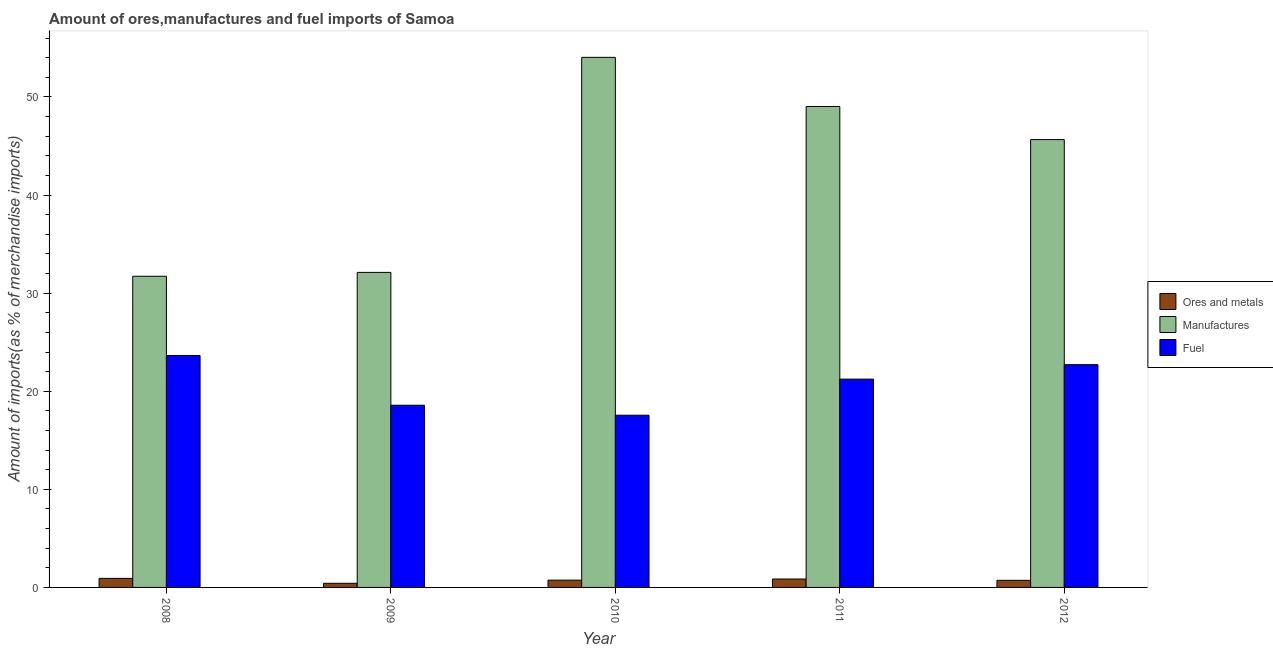How many groups of bars are there?
Your response must be concise. 5. Are the number of bars on each tick of the X-axis equal?
Your answer should be compact. Yes. How many bars are there on the 2nd tick from the left?
Provide a short and direct response. 3. How many bars are there on the 2nd tick from the right?
Offer a very short reply. 3. What is the percentage of fuel imports in 2009?
Keep it short and to the point. 18.58. Across all years, what is the maximum percentage of fuel imports?
Provide a short and direct response. 23.65. Across all years, what is the minimum percentage of manufactures imports?
Ensure brevity in your answer.  31.72. What is the total percentage of ores and metals imports in the graph?
Keep it short and to the point. 3.67. What is the difference between the percentage of manufactures imports in 2009 and that in 2011?
Ensure brevity in your answer.  -16.92. What is the difference between the percentage of ores and metals imports in 2011 and the percentage of manufactures imports in 2008?
Ensure brevity in your answer.  -0.06. What is the average percentage of manufactures imports per year?
Give a very brief answer. 42.51. In the year 2012, what is the difference between the percentage of ores and metals imports and percentage of fuel imports?
Your response must be concise. 0. In how many years, is the percentage of ores and metals imports greater than 2 %?
Offer a terse response. 0. What is the ratio of the percentage of fuel imports in 2008 to that in 2009?
Give a very brief answer. 1.27. Is the percentage of ores and metals imports in 2008 less than that in 2009?
Make the answer very short. No. What is the difference between the highest and the second highest percentage of ores and metals imports?
Your answer should be compact. 0.06. What is the difference between the highest and the lowest percentage of manufactures imports?
Your answer should be compact. 22.32. In how many years, is the percentage of fuel imports greater than the average percentage of fuel imports taken over all years?
Your response must be concise. 3. What does the 3rd bar from the left in 2008 represents?
Your answer should be compact. Fuel. What does the 2nd bar from the right in 2010 represents?
Offer a very short reply. Manufactures. How many bars are there?
Provide a short and direct response. 15. Are all the bars in the graph horizontal?
Offer a terse response. No. What is the difference between two consecutive major ticks on the Y-axis?
Provide a short and direct response. 10. Where does the legend appear in the graph?
Your answer should be very brief. Center right. How are the legend labels stacked?
Keep it short and to the point. Vertical. What is the title of the graph?
Provide a succinct answer. Amount of ores,manufactures and fuel imports of Samoa. Does "Infant(female)" appear as one of the legend labels in the graph?
Your response must be concise. No. What is the label or title of the X-axis?
Provide a succinct answer. Year. What is the label or title of the Y-axis?
Ensure brevity in your answer.  Amount of imports(as % of merchandise imports). What is the Amount of imports(as % of merchandise imports) of Ores and metals in 2008?
Give a very brief answer. 0.92. What is the Amount of imports(as % of merchandise imports) in Manufactures in 2008?
Your response must be concise. 31.72. What is the Amount of imports(as % of merchandise imports) of Fuel in 2008?
Your response must be concise. 23.65. What is the Amount of imports(as % of merchandise imports) in Ores and metals in 2009?
Your answer should be compact. 0.42. What is the Amount of imports(as % of merchandise imports) of Manufactures in 2009?
Provide a succinct answer. 32.12. What is the Amount of imports(as % of merchandise imports) in Fuel in 2009?
Your answer should be compact. 18.58. What is the Amount of imports(as % of merchandise imports) of Ores and metals in 2010?
Your answer should be compact. 0.74. What is the Amount of imports(as % of merchandise imports) of Manufactures in 2010?
Your response must be concise. 54.04. What is the Amount of imports(as % of merchandise imports) of Fuel in 2010?
Ensure brevity in your answer.  17.56. What is the Amount of imports(as % of merchandise imports) of Ores and metals in 2011?
Your response must be concise. 0.86. What is the Amount of imports(as % of merchandise imports) of Manufactures in 2011?
Give a very brief answer. 49.03. What is the Amount of imports(as % of merchandise imports) in Fuel in 2011?
Provide a short and direct response. 21.24. What is the Amount of imports(as % of merchandise imports) in Ores and metals in 2012?
Give a very brief answer. 0.72. What is the Amount of imports(as % of merchandise imports) of Manufactures in 2012?
Ensure brevity in your answer.  45.66. What is the Amount of imports(as % of merchandise imports) of Fuel in 2012?
Offer a terse response. 22.71. Across all years, what is the maximum Amount of imports(as % of merchandise imports) in Ores and metals?
Provide a succinct answer. 0.92. Across all years, what is the maximum Amount of imports(as % of merchandise imports) in Manufactures?
Offer a terse response. 54.04. Across all years, what is the maximum Amount of imports(as % of merchandise imports) of Fuel?
Offer a terse response. 23.65. Across all years, what is the minimum Amount of imports(as % of merchandise imports) of Ores and metals?
Give a very brief answer. 0.42. Across all years, what is the minimum Amount of imports(as % of merchandise imports) in Manufactures?
Offer a terse response. 31.72. Across all years, what is the minimum Amount of imports(as % of merchandise imports) in Fuel?
Your response must be concise. 17.56. What is the total Amount of imports(as % of merchandise imports) in Ores and metals in the graph?
Provide a succinct answer. 3.67. What is the total Amount of imports(as % of merchandise imports) in Manufactures in the graph?
Your answer should be very brief. 212.57. What is the total Amount of imports(as % of merchandise imports) of Fuel in the graph?
Offer a very short reply. 103.73. What is the difference between the Amount of imports(as % of merchandise imports) in Ores and metals in 2008 and that in 2009?
Your answer should be compact. 0.5. What is the difference between the Amount of imports(as % of merchandise imports) of Manufactures in 2008 and that in 2009?
Make the answer very short. -0.39. What is the difference between the Amount of imports(as % of merchandise imports) of Fuel in 2008 and that in 2009?
Keep it short and to the point. 5.07. What is the difference between the Amount of imports(as % of merchandise imports) in Ores and metals in 2008 and that in 2010?
Offer a terse response. 0.18. What is the difference between the Amount of imports(as % of merchandise imports) in Manufactures in 2008 and that in 2010?
Your response must be concise. -22.32. What is the difference between the Amount of imports(as % of merchandise imports) in Fuel in 2008 and that in 2010?
Your answer should be very brief. 6.09. What is the difference between the Amount of imports(as % of merchandise imports) in Ores and metals in 2008 and that in 2011?
Offer a terse response. 0.06. What is the difference between the Amount of imports(as % of merchandise imports) of Manufactures in 2008 and that in 2011?
Offer a terse response. -17.31. What is the difference between the Amount of imports(as % of merchandise imports) in Fuel in 2008 and that in 2011?
Offer a terse response. 2.41. What is the difference between the Amount of imports(as % of merchandise imports) in Ores and metals in 2008 and that in 2012?
Ensure brevity in your answer.  0.2. What is the difference between the Amount of imports(as % of merchandise imports) of Manufactures in 2008 and that in 2012?
Your answer should be compact. -13.93. What is the difference between the Amount of imports(as % of merchandise imports) in Fuel in 2008 and that in 2012?
Provide a succinct answer. 0.94. What is the difference between the Amount of imports(as % of merchandise imports) in Ores and metals in 2009 and that in 2010?
Your response must be concise. -0.32. What is the difference between the Amount of imports(as % of merchandise imports) in Manufactures in 2009 and that in 2010?
Offer a very short reply. -21.93. What is the difference between the Amount of imports(as % of merchandise imports) in Fuel in 2009 and that in 2010?
Make the answer very short. 1.02. What is the difference between the Amount of imports(as % of merchandise imports) in Ores and metals in 2009 and that in 2011?
Offer a very short reply. -0.44. What is the difference between the Amount of imports(as % of merchandise imports) of Manufactures in 2009 and that in 2011?
Your answer should be compact. -16.92. What is the difference between the Amount of imports(as % of merchandise imports) in Fuel in 2009 and that in 2011?
Give a very brief answer. -2.66. What is the difference between the Amount of imports(as % of merchandise imports) in Ores and metals in 2009 and that in 2012?
Provide a short and direct response. -0.3. What is the difference between the Amount of imports(as % of merchandise imports) in Manufactures in 2009 and that in 2012?
Make the answer very short. -13.54. What is the difference between the Amount of imports(as % of merchandise imports) of Fuel in 2009 and that in 2012?
Offer a very short reply. -4.14. What is the difference between the Amount of imports(as % of merchandise imports) in Ores and metals in 2010 and that in 2011?
Ensure brevity in your answer.  -0.11. What is the difference between the Amount of imports(as % of merchandise imports) of Manufactures in 2010 and that in 2011?
Your answer should be compact. 5.01. What is the difference between the Amount of imports(as % of merchandise imports) of Fuel in 2010 and that in 2011?
Provide a succinct answer. -3.68. What is the difference between the Amount of imports(as % of merchandise imports) of Ores and metals in 2010 and that in 2012?
Provide a short and direct response. 0.02. What is the difference between the Amount of imports(as % of merchandise imports) of Manufactures in 2010 and that in 2012?
Your response must be concise. 8.39. What is the difference between the Amount of imports(as % of merchandise imports) in Fuel in 2010 and that in 2012?
Your response must be concise. -5.16. What is the difference between the Amount of imports(as % of merchandise imports) in Ores and metals in 2011 and that in 2012?
Provide a short and direct response. 0.13. What is the difference between the Amount of imports(as % of merchandise imports) of Manufactures in 2011 and that in 2012?
Provide a succinct answer. 3.38. What is the difference between the Amount of imports(as % of merchandise imports) in Fuel in 2011 and that in 2012?
Your response must be concise. -1.47. What is the difference between the Amount of imports(as % of merchandise imports) of Ores and metals in 2008 and the Amount of imports(as % of merchandise imports) of Manufactures in 2009?
Provide a succinct answer. -31.19. What is the difference between the Amount of imports(as % of merchandise imports) in Ores and metals in 2008 and the Amount of imports(as % of merchandise imports) in Fuel in 2009?
Provide a succinct answer. -17.65. What is the difference between the Amount of imports(as % of merchandise imports) of Manufactures in 2008 and the Amount of imports(as % of merchandise imports) of Fuel in 2009?
Offer a terse response. 13.15. What is the difference between the Amount of imports(as % of merchandise imports) in Ores and metals in 2008 and the Amount of imports(as % of merchandise imports) in Manufactures in 2010?
Your response must be concise. -53.12. What is the difference between the Amount of imports(as % of merchandise imports) of Ores and metals in 2008 and the Amount of imports(as % of merchandise imports) of Fuel in 2010?
Provide a short and direct response. -16.63. What is the difference between the Amount of imports(as % of merchandise imports) in Manufactures in 2008 and the Amount of imports(as % of merchandise imports) in Fuel in 2010?
Your response must be concise. 14.17. What is the difference between the Amount of imports(as % of merchandise imports) of Ores and metals in 2008 and the Amount of imports(as % of merchandise imports) of Manufactures in 2011?
Provide a succinct answer. -48.11. What is the difference between the Amount of imports(as % of merchandise imports) of Ores and metals in 2008 and the Amount of imports(as % of merchandise imports) of Fuel in 2011?
Make the answer very short. -20.31. What is the difference between the Amount of imports(as % of merchandise imports) of Manufactures in 2008 and the Amount of imports(as % of merchandise imports) of Fuel in 2011?
Your answer should be compact. 10.49. What is the difference between the Amount of imports(as % of merchandise imports) of Ores and metals in 2008 and the Amount of imports(as % of merchandise imports) of Manufactures in 2012?
Provide a short and direct response. -44.73. What is the difference between the Amount of imports(as % of merchandise imports) of Ores and metals in 2008 and the Amount of imports(as % of merchandise imports) of Fuel in 2012?
Provide a succinct answer. -21.79. What is the difference between the Amount of imports(as % of merchandise imports) in Manufactures in 2008 and the Amount of imports(as % of merchandise imports) in Fuel in 2012?
Keep it short and to the point. 9.01. What is the difference between the Amount of imports(as % of merchandise imports) in Ores and metals in 2009 and the Amount of imports(as % of merchandise imports) in Manufactures in 2010?
Give a very brief answer. -53.62. What is the difference between the Amount of imports(as % of merchandise imports) in Ores and metals in 2009 and the Amount of imports(as % of merchandise imports) in Fuel in 2010?
Ensure brevity in your answer.  -17.14. What is the difference between the Amount of imports(as % of merchandise imports) in Manufactures in 2009 and the Amount of imports(as % of merchandise imports) in Fuel in 2010?
Ensure brevity in your answer.  14.56. What is the difference between the Amount of imports(as % of merchandise imports) of Ores and metals in 2009 and the Amount of imports(as % of merchandise imports) of Manufactures in 2011?
Ensure brevity in your answer.  -48.61. What is the difference between the Amount of imports(as % of merchandise imports) of Ores and metals in 2009 and the Amount of imports(as % of merchandise imports) of Fuel in 2011?
Ensure brevity in your answer.  -20.82. What is the difference between the Amount of imports(as % of merchandise imports) of Manufactures in 2009 and the Amount of imports(as % of merchandise imports) of Fuel in 2011?
Give a very brief answer. 10.88. What is the difference between the Amount of imports(as % of merchandise imports) in Ores and metals in 2009 and the Amount of imports(as % of merchandise imports) in Manufactures in 2012?
Your answer should be compact. -45.24. What is the difference between the Amount of imports(as % of merchandise imports) in Ores and metals in 2009 and the Amount of imports(as % of merchandise imports) in Fuel in 2012?
Your response must be concise. -22.29. What is the difference between the Amount of imports(as % of merchandise imports) of Manufactures in 2009 and the Amount of imports(as % of merchandise imports) of Fuel in 2012?
Ensure brevity in your answer.  9.41. What is the difference between the Amount of imports(as % of merchandise imports) in Ores and metals in 2010 and the Amount of imports(as % of merchandise imports) in Manufactures in 2011?
Ensure brevity in your answer.  -48.29. What is the difference between the Amount of imports(as % of merchandise imports) of Ores and metals in 2010 and the Amount of imports(as % of merchandise imports) of Fuel in 2011?
Keep it short and to the point. -20.49. What is the difference between the Amount of imports(as % of merchandise imports) of Manufactures in 2010 and the Amount of imports(as % of merchandise imports) of Fuel in 2011?
Offer a very short reply. 32.81. What is the difference between the Amount of imports(as % of merchandise imports) in Ores and metals in 2010 and the Amount of imports(as % of merchandise imports) in Manufactures in 2012?
Offer a terse response. -44.91. What is the difference between the Amount of imports(as % of merchandise imports) of Ores and metals in 2010 and the Amount of imports(as % of merchandise imports) of Fuel in 2012?
Your answer should be compact. -21.97. What is the difference between the Amount of imports(as % of merchandise imports) of Manufactures in 2010 and the Amount of imports(as % of merchandise imports) of Fuel in 2012?
Your answer should be compact. 31.33. What is the difference between the Amount of imports(as % of merchandise imports) in Ores and metals in 2011 and the Amount of imports(as % of merchandise imports) in Manufactures in 2012?
Your answer should be very brief. -44.8. What is the difference between the Amount of imports(as % of merchandise imports) of Ores and metals in 2011 and the Amount of imports(as % of merchandise imports) of Fuel in 2012?
Offer a terse response. -21.85. What is the difference between the Amount of imports(as % of merchandise imports) in Manufactures in 2011 and the Amount of imports(as % of merchandise imports) in Fuel in 2012?
Offer a very short reply. 26.32. What is the average Amount of imports(as % of merchandise imports) in Ores and metals per year?
Ensure brevity in your answer.  0.73. What is the average Amount of imports(as % of merchandise imports) of Manufactures per year?
Provide a short and direct response. 42.51. What is the average Amount of imports(as % of merchandise imports) in Fuel per year?
Offer a terse response. 20.75. In the year 2008, what is the difference between the Amount of imports(as % of merchandise imports) in Ores and metals and Amount of imports(as % of merchandise imports) in Manufactures?
Your answer should be compact. -30.8. In the year 2008, what is the difference between the Amount of imports(as % of merchandise imports) of Ores and metals and Amount of imports(as % of merchandise imports) of Fuel?
Make the answer very short. -22.73. In the year 2008, what is the difference between the Amount of imports(as % of merchandise imports) in Manufactures and Amount of imports(as % of merchandise imports) in Fuel?
Ensure brevity in your answer.  8.07. In the year 2009, what is the difference between the Amount of imports(as % of merchandise imports) in Ores and metals and Amount of imports(as % of merchandise imports) in Manufactures?
Make the answer very short. -31.7. In the year 2009, what is the difference between the Amount of imports(as % of merchandise imports) of Ores and metals and Amount of imports(as % of merchandise imports) of Fuel?
Provide a succinct answer. -18.16. In the year 2009, what is the difference between the Amount of imports(as % of merchandise imports) in Manufactures and Amount of imports(as % of merchandise imports) in Fuel?
Your answer should be compact. 13.54. In the year 2010, what is the difference between the Amount of imports(as % of merchandise imports) in Ores and metals and Amount of imports(as % of merchandise imports) in Manufactures?
Offer a terse response. -53.3. In the year 2010, what is the difference between the Amount of imports(as % of merchandise imports) of Ores and metals and Amount of imports(as % of merchandise imports) of Fuel?
Offer a terse response. -16.81. In the year 2010, what is the difference between the Amount of imports(as % of merchandise imports) of Manufactures and Amount of imports(as % of merchandise imports) of Fuel?
Make the answer very short. 36.49. In the year 2011, what is the difference between the Amount of imports(as % of merchandise imports) of Ores and metals and Amount of imports(as % of merchandise imports) of Manufactures?
Offer a very short reply. -48.17. In the year 2011, what is the difference between the Amount of imports(as % of merchandise imports) in Ores and metals and Amount of imports(as % of merchandise imports) in Fuel?
Offer a very short reply. -20.38. In the year 2011, what is the difference between the Amount of imports(as % of merchandise imports) in Manufactures and Amount of imports(as % of merchandise imports) in Fuel?
Your response must be concise. 27.8. In the year 2012, what is the difference between the Amount of imports(as % of merchandise imports) in Ores and metals and Amount of imports(as % of merchandise imports) in Manufactures?
Ensure brevity in your answer.  -44.93. In the year 2012, what is the difference between the Amount of imports(as % of merchandise imports) in Ores and metals and Amount of imports(as % of merchandise imports) in Fuel?
Keep it short and to the point. -21.99. In the year 2012, what is the difference between the Amount of imports(as % of merchandise imports) of Manufactures and Amount of imports(as % of merchandise imports) of Fuel?
Offer a terse response. 22.94. What is the ratio of the Amount of imports(as % of merchandise imports) of Ores and metals in 2008 to that in 2009?
Your response must be concise. 2.19. What is the ratio of the Amount of imports(as % of merchandise imports) in Manufactures in 2008 to that in 2009?
Ensure brevity in your answer.  0.99. What is the ratio of the Amount of imports(as % of merchandise imports) in Fuel in 2008 to that in 2009?
Offer a very short reply. 1.27. What is the ratio of the Amount of imports(as % of merchandise imports) of Ores and metals in 2008 to that in 2010?
Keep it short and to the point. 1.24. What is the ratio of the Amount of imports(as % of merchandise imports) in Manufactures in 2008 to that in 2010?
Keep it short and to the point. 0.59. What is the ratio of the Amount of imports(as % of merchandise imports) of Fuel in 2008 to that in 2010?
Make the answer very short. 1.35. What is the ratio of the Amount of imports(as % of merchandise imports) in Ores and metals in 2008 to that in 2011?
Your response must be concise. 1.07. What is the ratio of the Amount of imports(as % of merchandise imports) of Manufactures in 2008 to that in 2011?
Make the answer very short. 0.65. What is the ratio of the Amount of imports(as % of merchandise imports) of Fuel in 2008 to that in 2011?
Provide a succinct answer. 1.11. What is the ratio of the Amount of imports(as % of merchandise imports) in Ores and metals in 2008 to that in 2012?
Ensure brevity in your answer.  1.27. What is the ratio of the Amount of imports(as % of merchandise imports) in Manufactures in 2008 to that in 2012?
Give a very brief answer. 0.69. What is the ratio of the Amount of imports(as % of merchandise imports) of Fuel in 2008 to that in 2012?
Give a very brief answer. 1.04. What is the ratio of the Amount of imports(as % of merchandise imports) of Ores and metals in 2009 to that in 2010?
Keep it short and to the point. 0.57. What is the ratio of the Amount of imports(as % of merchandise imports) in Manufactures in 2009 to that in 2010?
Your response must be concise. 0.59. What is the ratio of the Amount of imports(as % of merchandise imports) in Fuel in 2009 to that in 2010?
Your answer should be very brief. 1.06. What is the ratio of the Amount of imports(as % of merchandise imports) in Ores and metals in 2009 to that in 2011?
Keep it short and to the point. 0.49. What is the ratio of the Amount of imports(as % of merchandise imports) in Manufactures in 2009 to that in 2011?
Your response must be concise. 0.66. What is the ratio of the Amount of imports(as % of merchandise imports) of Fuel in 2009 to that in 2011?
Your answer should be compact. 0.87. What is the ratio of the Amount of imports(as % of merchandise imports) in Ores and metals in 2009 to that in 2012?
Give a very brief answer. 0.58. What is the ratio of the Amount of imports(as % of merchandise imports) of Manufactures in 2009 to that in 2012?
Your answer should be very brief. 0.7. What is the ratio of the Amount of imports(as % of merchandise imports) in Fuel in 2009 to that in 2012?
Provide a succinct answer. 0.82. What is the ratio of the Amount of imports(as % of merchandise imports) of Ores and metals in 2010 to that in 2011?
Ensure brevity in your answer.  0.87. What is the ratio of the Amount of imports(as % of merchandise imports) in Manufactures in 2010 to that in 2011?
Your answer should be very brief. 1.1. What is the ratio of the Amount of imports(as % of merchandise imports) of Fuel in 2010 to that in 2011?
Ensure brevity in your answer.  0.83. What is the ratio of the Amount of imports(as % of merchandise imports) of Ores and metals in 2010 to that in 2012?
Keep it short and to the point. 1.03. What is the ratio of the Amount of imports(as % of merchandise imports) in Manufactures in 2010 to that in 2012?
Provide a short and direct response. 1.18. What is the ratio of the Amount of imports(as % of merchandise imports) of Fuel in 2010 to that in 2012?
Your response must be concise. 0.77. What is the ratio of the Amount of imports(as % of merchandise imports) in Ores and metals in 2011 to that in 2012?
Offer a very short reply. 1.18. What is the ratio of the Amount of imports(as % of merchandise imports) in Manufactures in 2011 to that in 2012?
Provide a short and direct response. 1.07. What is the ratio of the Amount of imports(as % of merchandise imports) of Fuel in 2011 to that in 2012?
Provide a succinct answer. 0.94. What is the difference between the highest and the second highest Amount of imports(as % of merchandise imports) of Ores and metals?
Your response must be concise. 0.06. What is the difference between the highest and the second highest Amount of imports(as % of merchandise imports) in Manufactures?
Provide a succinct answer. 5.01. What is the difference between the highest and the second highest Amount of imports(as % of merchandise imports) of Fuel?
Provide a short and direct response. 0.94. What is the difference between the highest and the lowest Amount of imports(as % of merchandise imports) of Ores and metals?
Offer a very short reply. 0.5. What is the difference between the highest and the lowest Amount of imports(as % of merchandise imports) in Manufactures?
Provide a short and direct response. 22.32. What is the difference between the highest and the lowest Amount of imports(as % of merchandise imports) of Fuel?
Your answer should be compact. 6.09. 